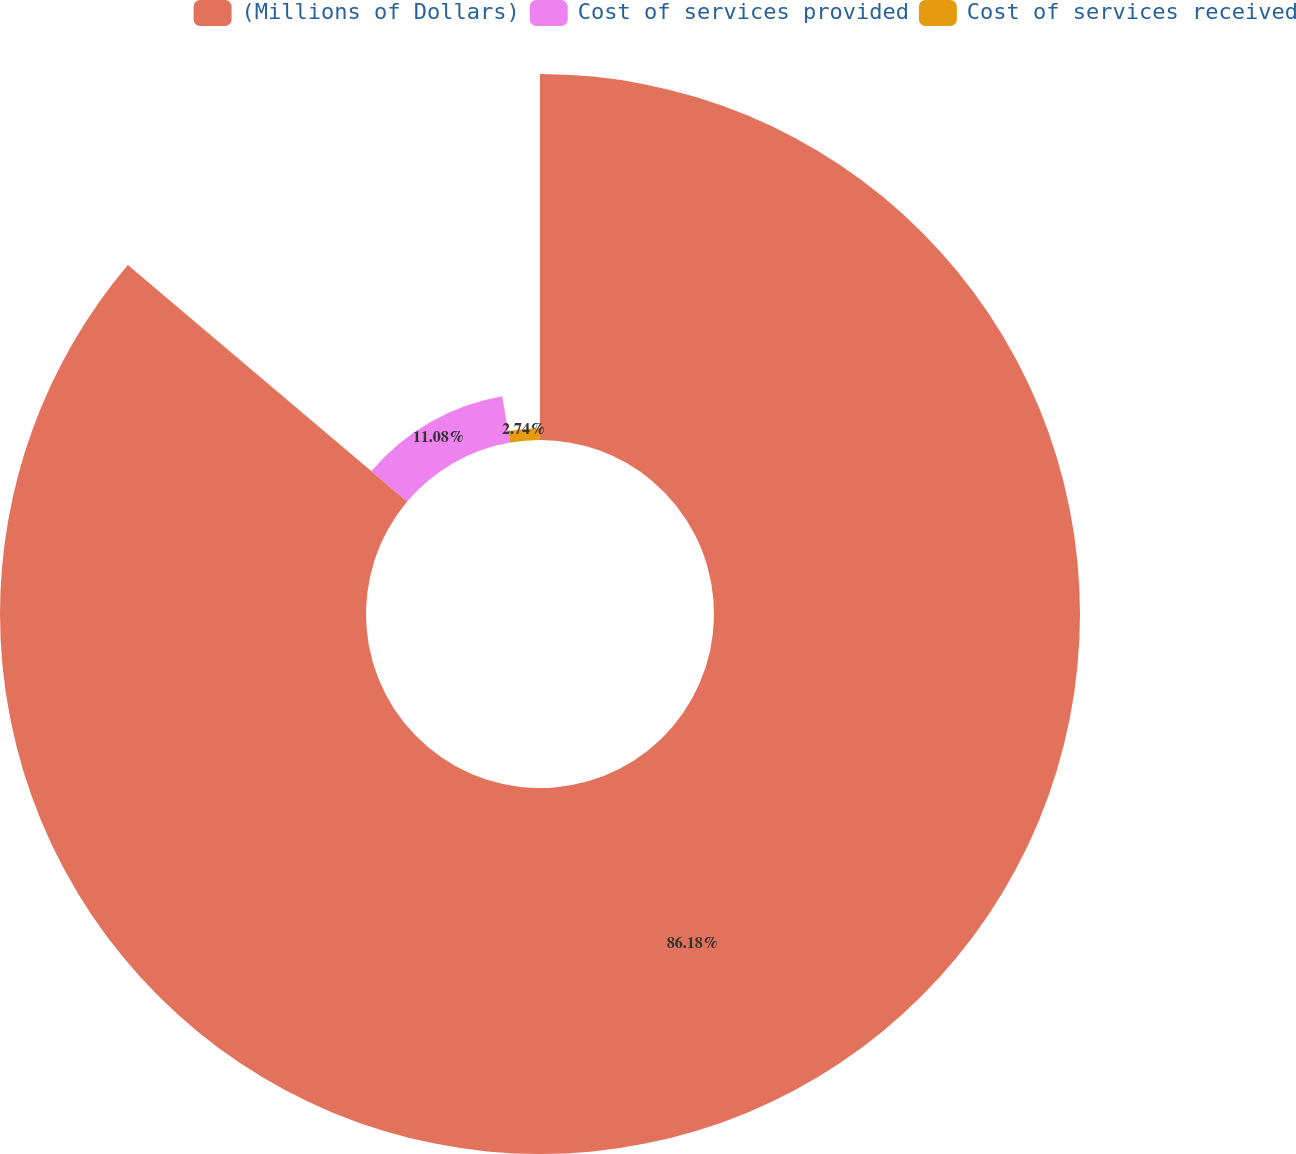<chart> <loc_0><loc_0><loc_500><loc_500><pie_chart><fcel>(Millions of Dollars)<fcel>Cost of services provided<fcel>Cost of services received<nl><fcel>86.18%<fcel>11.08%<fcel>2.74%<nl></chart> 